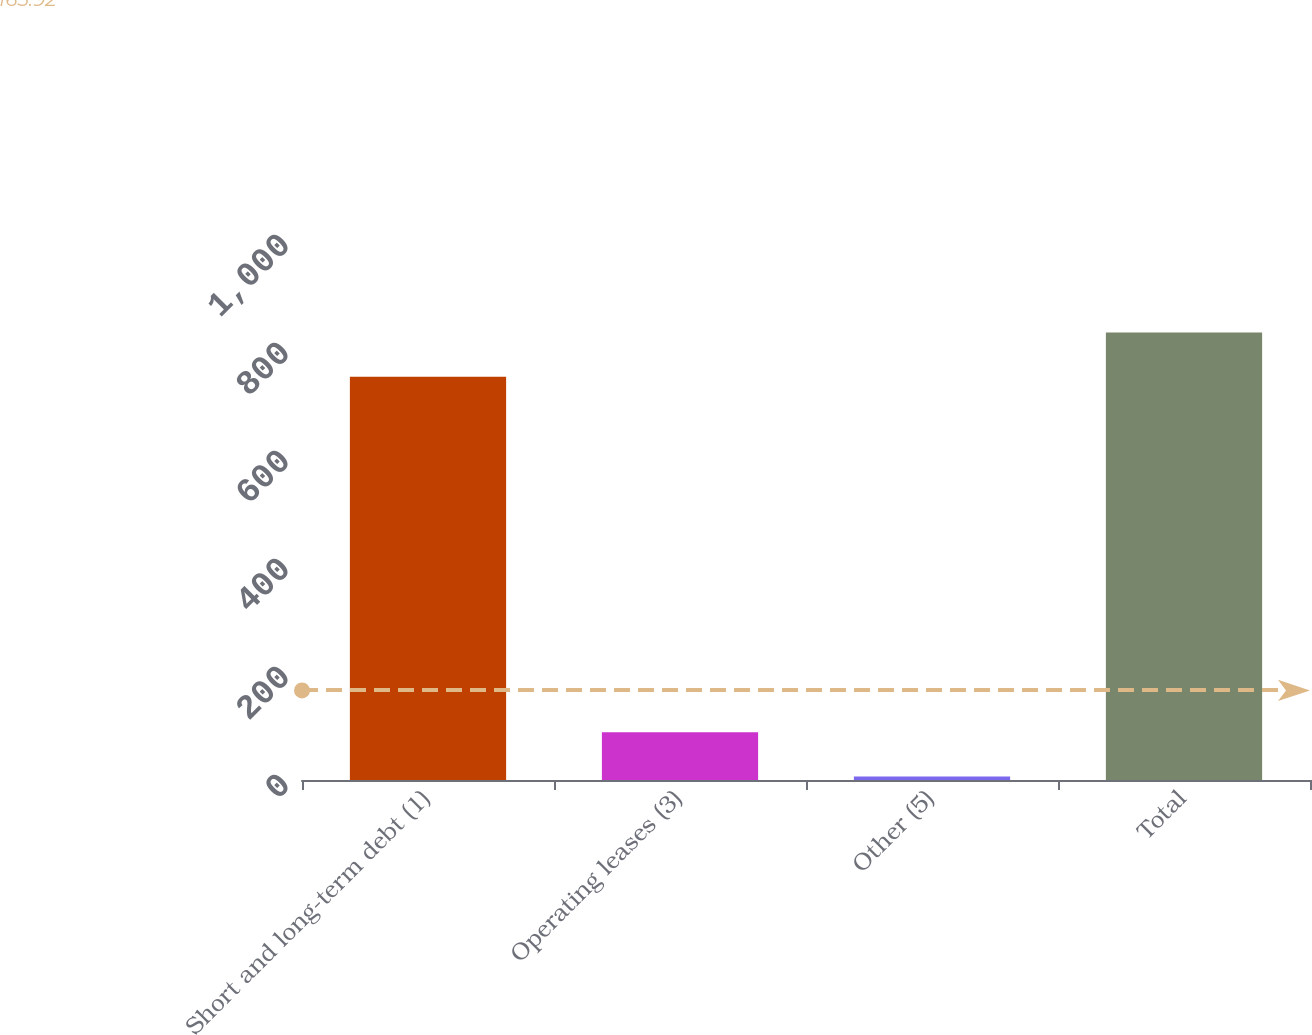Convert chart to OTSL. <chart><loc_0><loc_0><loc_500><loc_500><bar_chart><fcel>Short and long-term debt (1)<fcel>Operating leases (3)<fcel>Other (5)<fcel>Total<nl><fcel>746.9<fcel>88.42<fcel>6.6<fcel>828.72<nl></chart> 